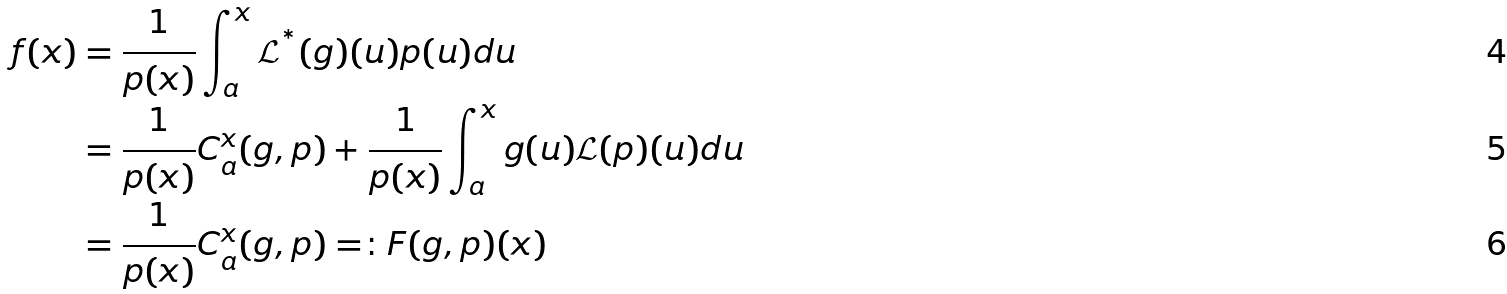Convert formula to latex. <formula><loc_0><loc_0><loc_500><loc_500>f ( x ) & = \frac { 1 } { p ( x ) } \int _ { a } ^ { x } \mathcal { L } ^ { ^ { * } } ( g ) ( u ) p ( u ) d u \\ & = \frac { 1 } { p ( x ) } C _ { a } ^ { x } ( g , p ) + \frac { 1 } { p ( x ) } \int _ { a } ^ { x } g ( u ) \mathcal { L } ( p ) ( u ) d u \\ & = \frac { 1 } { p ( x ) } C _ { a } ^ { x } ( g , p ) = \colon F ( g , p ) ( x )</formula> 